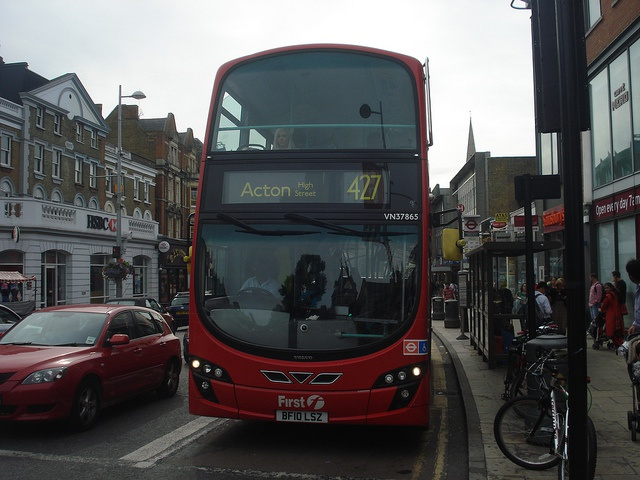Describe the objects in this image and their specific colors. I can see bus in lightgray, black, purple, and maroon tones, car in lightgray, black, darkgray, gray, and maroon tones, bicycle in lightgray, black, gray, and darkgray tones, people in lightgray, black, maroon, and gray tones, and people in lightgray, purple, darkblue, black, and blue tones in this image. 